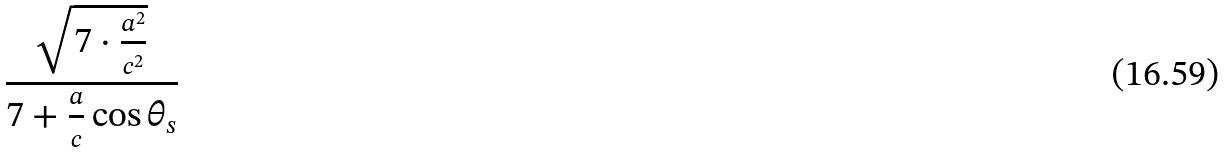Convert formula to latex. <formula><loc_0><loc_0><loc_500><loc_500>\frac { \sqrt { 7 \cdot \frac { a ^ { 2 } } { c ^ { 2 } } } } { 7 + \frac { a } { c } \cos \theta _ { s } }</formula> 